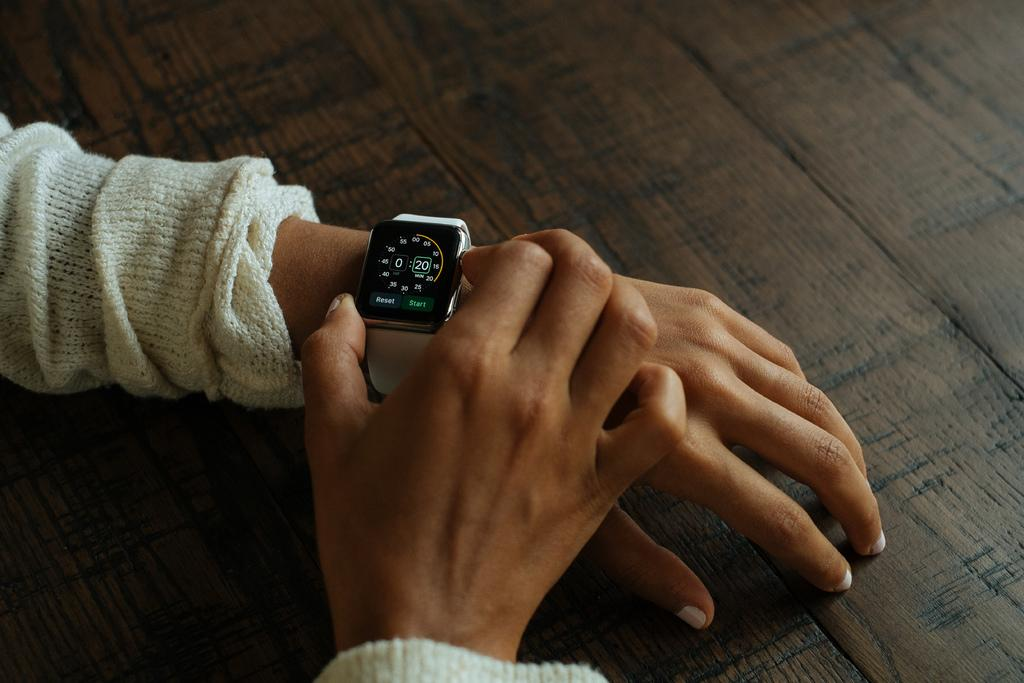<image>
Render a clear and concise summary of the photo. A person is wearing a watch that has options to Reset and Start on the face. 